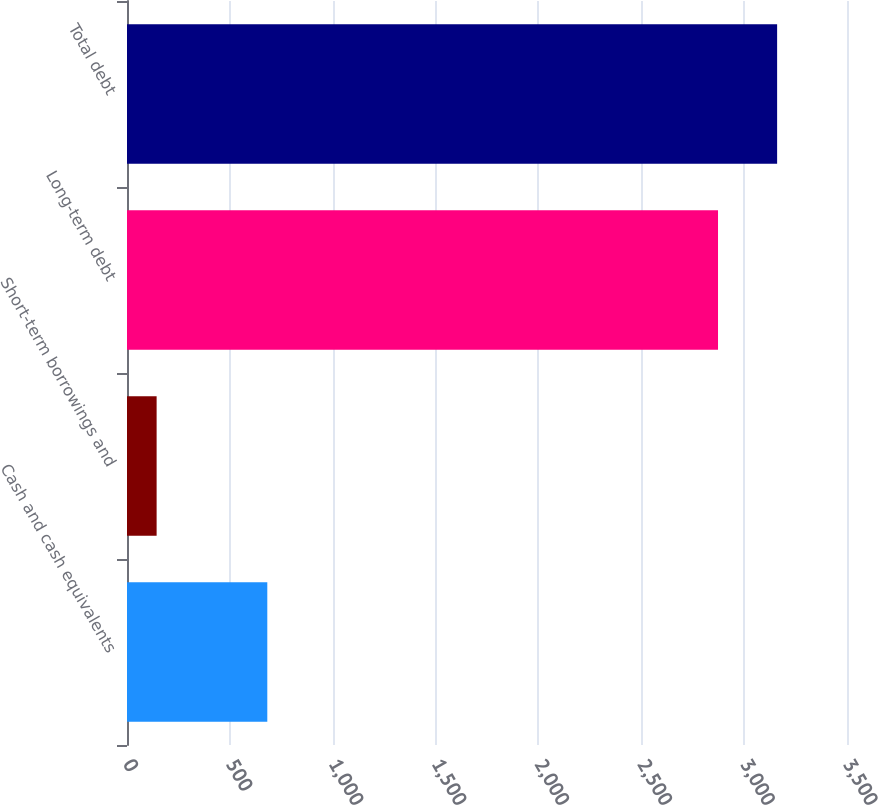<chart> <loc_0><loc_0><loc_500><loc_500><bar_chart><fcel>Cash and cash equivalents<fcel>Short-term borrowings and<fcel>Long-term debt<fcel>Total debt<nl><fcel>682<fcel>144<fcel>2873<fcel>3160.3<nl></chart> 